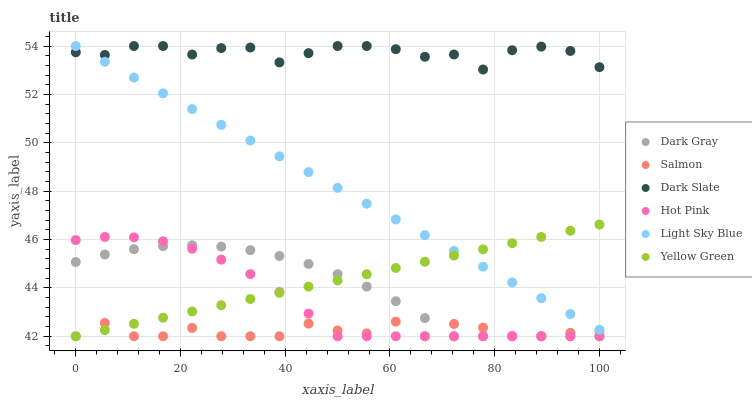Does Salmon have the minimum area under the curve?
Answer yes or no. Yes. Does Dark Slate have the maximum area under the curve?
Answer yes or no. Yes. Does Hot Pink have the minimum area under the curve?
Answer yes or no. No. Does Hot Pink have the maximum area under the curve?
Answer yes or no. No. Is Yellow Green the smoothest?
Answer yes or no. Yes. Is Salmon the roughest?
Answer yes or no. Yes. Is Hot Pink the smoothest?
Answer yes or no. No. Is Hot Pink the roughest?
Answer yes or no. No. Does Yellow Green have the lowest value?
Answer yes or no. Yes. Does Dark Slate have the lowest value?
Answer yes or no. No. Does Light Sky Blue have the highest value?
Answer yes or no. Yes. Does Hot Pink have the highest value?
Answer yes or no. No. Is Hot Pink less than Dark Slate?
Answer yes or no. Yes. Is Light Sky Blue greater than Salmon?
Answer yes or no. Yes. Does Light Sky Blue intersect Yellow Green?
Answer yes or no. Yes. Is Light Sky Blue less than Yellow Green?
Answer yes or no. No. Is Light Sky Blue greater than Yellow Green?
Answer yes or no. No. Does Hot Pink intersect Dark Slate?
Answer yes or no. No. 